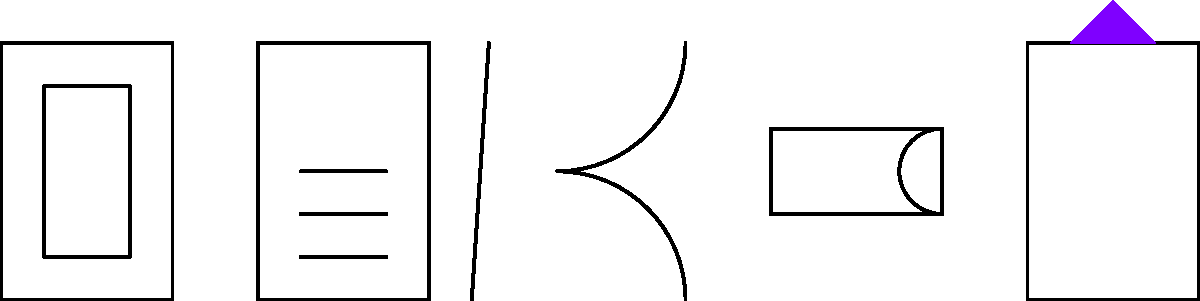Which of the illustrated items is commonly used to retrieve micro-caches from hard-to-reach places or to manipulate small parts of geocaches? To answer this question, let's analyze each item in the illustration:

1. Top-left: This appears to be a GPS device, used for navigation to geocache locations.
2. Center-left: This looks like a logbook and pen, used for recording finds.
3. Center: This item has a distinctive pincer-like shape, characteristic of tweezers.
4. Bottom-right: This cylindrical object with a curved end is likely a flashlight.
5. Far-right: The object with a triangular purple light appears to be a UV light.

Among these items, tweezers are specifically designed for manipulating small objects and reaching into tight spaces. In geocaching, they are often used to:
- Extract small micro-caches from crevices or tight spots
- Handle tiny log rolls without damaging them
- Manipulate small parts of puzzle caches

Therefore, the item that best fits the description in the question is the tweezers.
Answer: Tweezers 